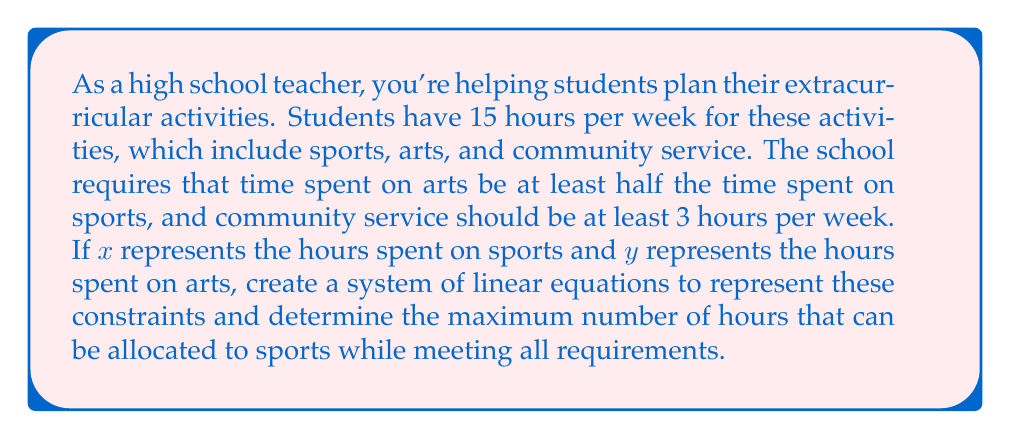Could you help me with this problem? Let's approach this step-by-step:

1) First, let's define our variables:
   $x$ = hours spent on sports
   $y$ = hours spent on arts
   Let's call the hours spent on community service $z$

2) Now, let's translate the given information into equations:

   Total time constraint: $x + y + z = 15$

   Arts time constraint: $y \geq \frac{1}{2}x$

   Community service constraint: $z \geq 3$

3) We want to maximize $x$, so we'll use the minimum values for $y$ and $z$:

   $y = \frac{1}{2}x$ and $z = 3$

4) Substituting these into our total time constraint:

   $x + \frac{1}{2}x + 3 = 15$

5) Simplify:

   $\frac{3}{2}x + 3 = 15$

6) Subtract 3 from both sides:

   $\frac{3}{2}x = 12$

7) Multiply both sides by $\frac{2}{3}$:

   $x = 12 \cdot \frac{2}{3} = 8$

8) Now that we know $x = 8$, we can calculate $y$:

   $y = \frac{1}{2}x = \frac{1}{2} \cdot 8 = 4$

9) We can verify our solution:
   Sports (x): 8 hours
   Arts (y): 4 hours
   Community service (z): 3 hours
   Total: 8 + 4 + 3 = 15 hours

This solution satisfies all constraints:
- Total time is 15 hours
- Arts time (4) is at least half of sports time (8)
- Community service is at least 3 hours
Answer: The maximum number of hours that can be allocated to sports while meeting all requirements is 8 hours. 